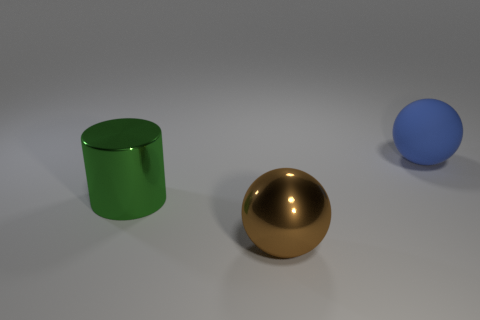What materials do the objects in the image appear to be made of? The objects in the image appear to be rendered with different textures suggestive of various materials. The green cylinder has a glossy texture that could be interpreted as a type of polished metal or plastic. The golden ball seems to have a reflective, shiny surface resembling metal, and the blue sphere has a diffuse, matte finish which could be likened to a rubber or painted surface. 